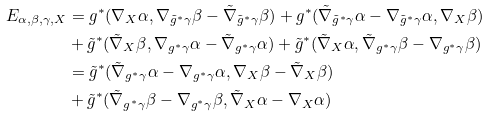Convert formula to latex. <formula><loc_0><loc_0><loc_500><loc_500>E _ { \alpha , \beta , \gamma , X } & = g ^ { * } ( \nabla _ { X } \alpha , \nabla _ { \tilde { g } ^ { * } \gamma } \beta - \tilde { \nabla } _ { \tilde { g } ^ { * } \gamma } \beta ) + g ^ { * } ( \tilde { \nabla } _ { \tilde { g } ^ { * } \gamma } \alpha - \nabla _ { \tilde { g } ^ { * } \gamma } \alpha , \nabla _ { X } \beta ) \\ & + \tilde { g } ^ { * } ( \tilde { \nabla } _ { X } \beta , \nabla _ { g ^ { * } \gamma } \alpha - \tilde { \nabla } _ { g ^ { * } \gamma } \alpha ) + \tilde { g } ^ { * } ( \tilde { \nabla } _ { X } \alpha , \tilde { \nabla } _ { g ^ { * } \gamma } \beta - \nabla _ { g ^ { * } \gamma } \beta ) \\ & = \tilde { g } ^ { * } ( \tilde { \nabla } _ { g ^ { * } \gamma } \alpha - \nabla _ { g ^ { * } \gamma } \alpha , \nabla _ { X } \beta - \tilde { \nabla } _ { X } \beta ) \\ & + \tilde { g } ^ { * } ( \tilde { \nabla } _ { g ^ { * } \gamma } \beta - \nabla _ { g ^ { * } \gamma } \beta , \tilde { \nabla } _ { X } \alpha - \nabla _ { X } \alpha ) \\</formula> 